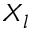Convert formula to latex. <formula><loc_0><loc_0><loc_500><loc_500>X _ { l }</formula> 